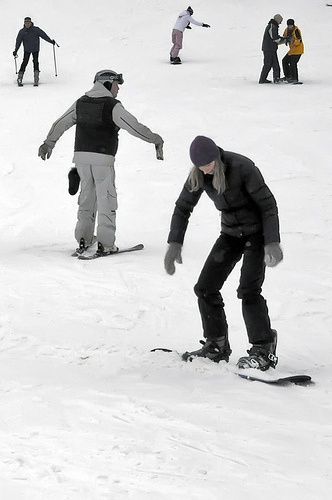Describe the objects in this image and their specific colors. I can see people in lightgray, black, gray, and darkgray tones, people in lightgray, gray, black, and white tones, people in lightgray, black, gray, white, and darkgray tones, snowboard in lightgray, black, gray, and darkgray tones, and people in lightgray, black, olive, and gray tones in this image. 